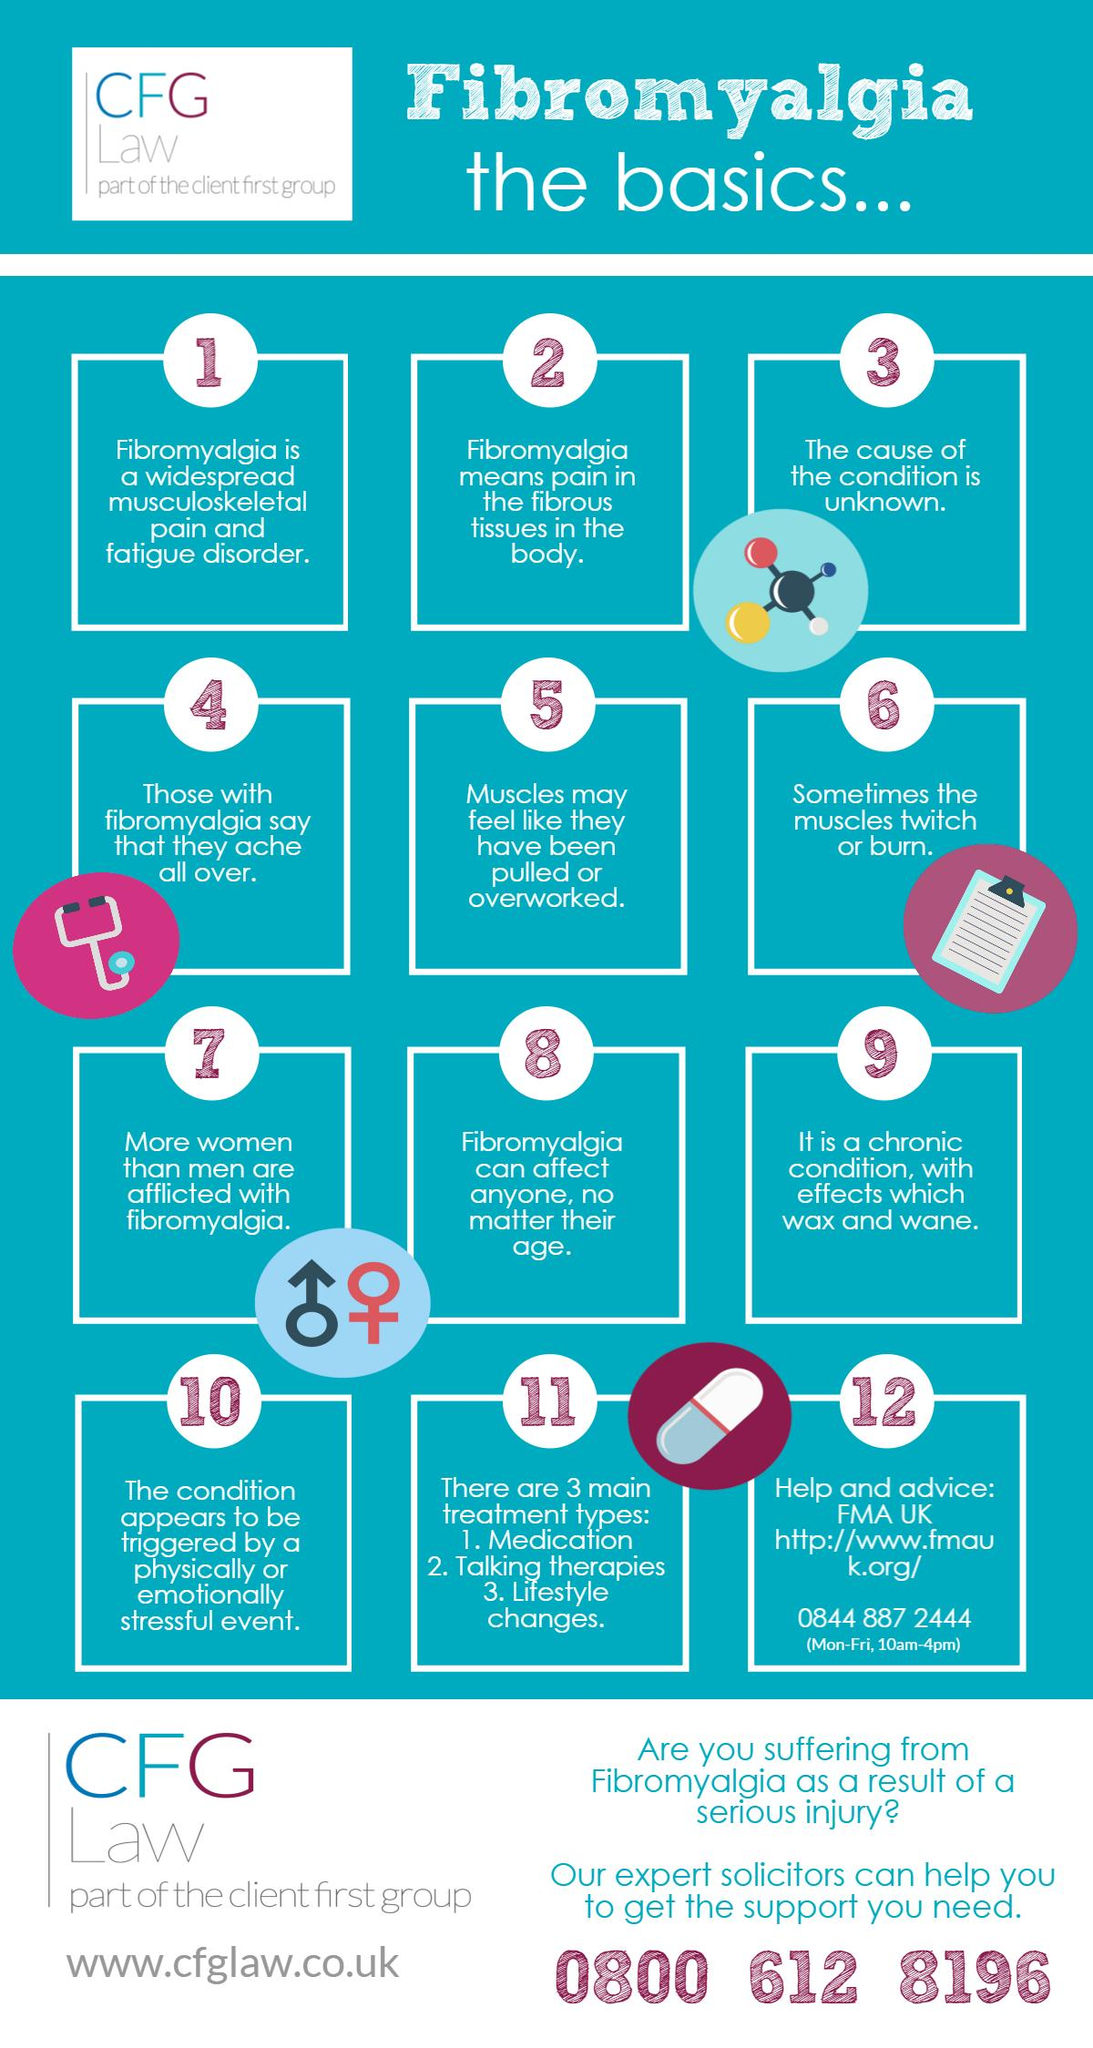Mention a couple of crucial points in this snapshot. Fibromyalgia is typically treated through a combination of medication, talking therapies, and lifestyle changes. These interventions are designed to alleviate the symptoms of fibromyalgia and improve a patient's overall quality of life. 